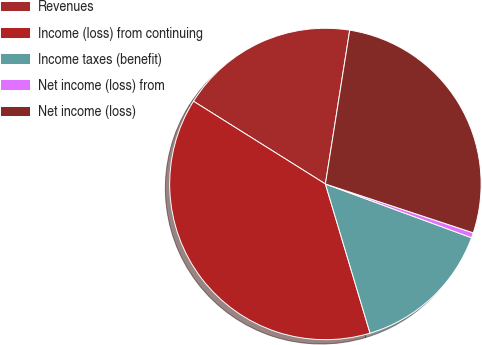Convert chart to OTSL. <chart><loc_0><loc_0><loc_500><loc_500><pie_chart><fcel>Revenues<fcel>Income (loss) from continuing<fcel>Income taxes (benefit)<fcel>Net income (loss) from<fcel>Net income (loss)<nl><fcel>18.58%<fcel>38.54%<fcel>14.76%<fcel>0.53%<fcel>27.58%<nl></chart> 